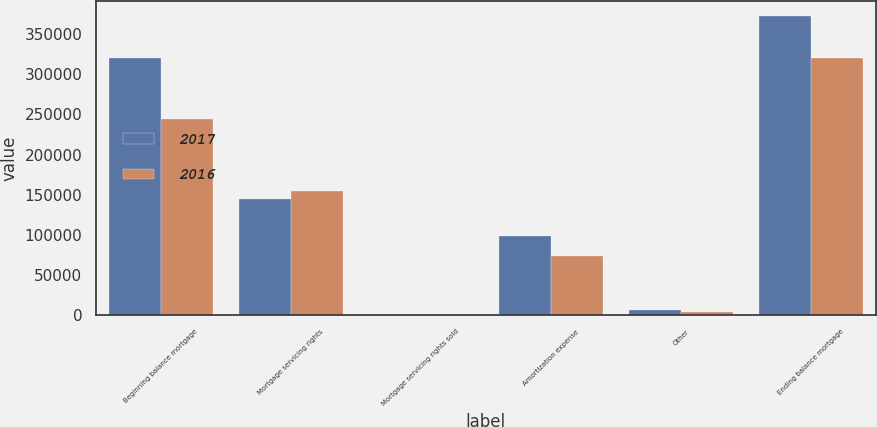Convert chart to OTSL. <chart><loc_0><loc_0><loc_500><loc_500><stacked_bar_chart><ecel><fcel>Beginning balance mortgage<fcel>Mortgage servicing rights<fcel>Mortgage servicing rights sold<fcel>Amortization expense<fcel>Other<fcel>Ending balance mortgage<nl><fcel>2017<fcel>320524<fcel>145103<fcel>71<fcel>98559<fcel>6134<fcel>373131<nl><fcel>2016<fcel>244723<fcel>154040<fcel>790<fcel>73273<fcel>4176<fcel>320524<nl></chart> 